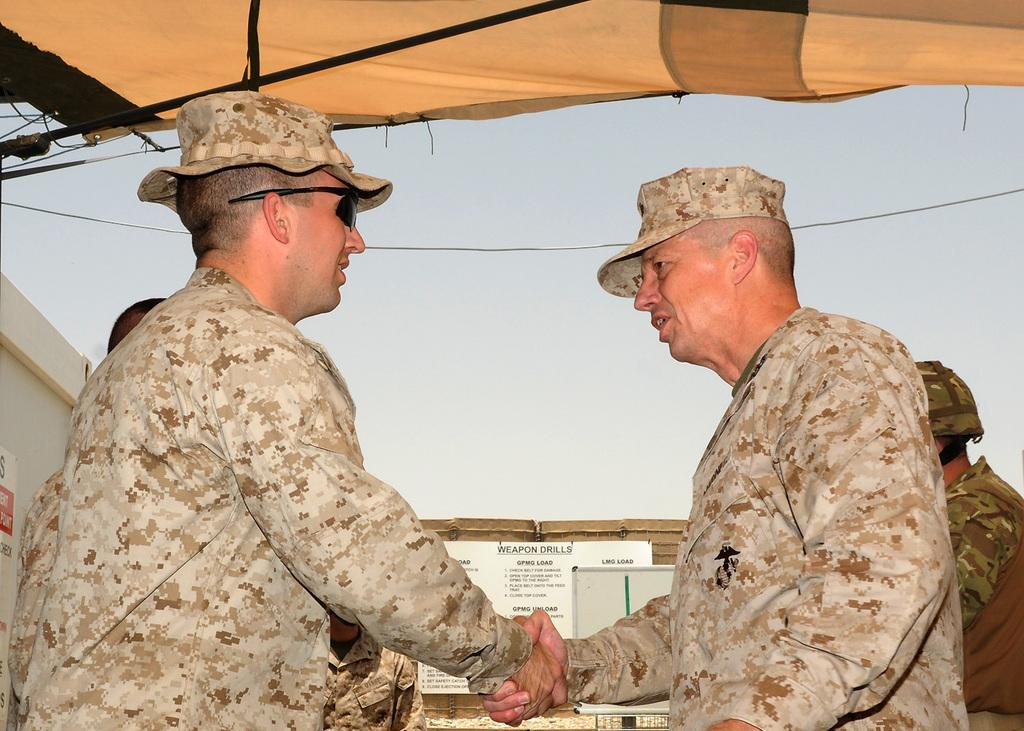What can be seen in the image involving people? There are people standing in the image. What type of temporary shelter is present in the image? There is a tent in the image. What is used for writing or displaying information in the image? There is a whiteboard and a display board in the image. Where are the sticky bills located in the image? The sticky bills are on the wall at the left side of the image. What type of steam can be seen coming from the people's stomachs in the image? There is no steam coming from the people's stomachs in the image; it is not present. What type of street is visible in the image? There is no street visible in the image; the image does not show any street. 